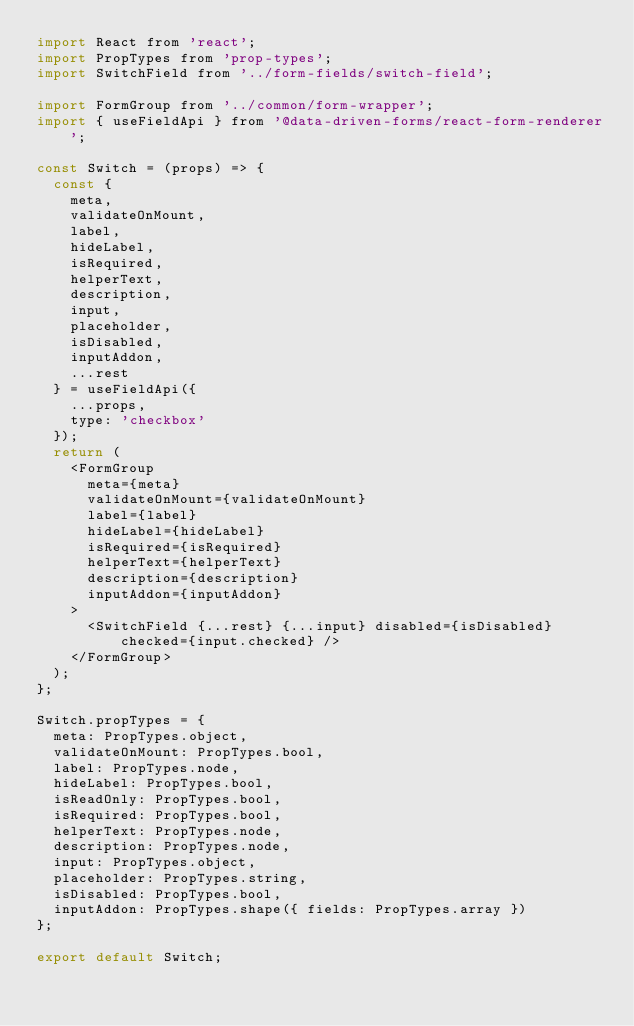Convert code to text. <code><loc_0><loc_0><loc_500><loc_500><_JavaScript_>import React from 'react';
import PropTypes from 'prop-types';
import SwitchField from '../form-fields/switch-field';

import FormGroup from '../common/form-wrapper';
import { useFieldApi } from '@data-driven-forms/react-form-renderer';

const Switch = (props) => {
  const {
    meta,
    validateOnMount,
    label,
    hideLabel,
    isRequired,
    helperText,
    description,
    input,
    placeholder,
    isDisabled,
    inputAddon,
    ...rest
  } = useFieldApi({
    ...props,
    type: 'checkbox'
  });
  return (
    <FormGroup
      meta={meta}
      validateOnMount={validateOnMount}
      label={label}
      hideLabel={hideLabel}
      isRequired={isRequired}
      helperText={helperText}
      description={description}
      inputAddon={inputAddon}
    >
      <SwitchField {...rest} {...input} disabled={isDisabled} checked={input.checked} />
    </FormGroup>
  );
};

Switch.propTypes = {
  meta: PropTypes.object,
  validateOnMount: PropTypes.bool,
  label: PropTypes.node,
  hideLabel: PropTypes.bool,
  isReadOnly: PropTypes.bool,
  isRequired: PropTypes.bool,
  helperText: PropTypes.node,
  description: PropTypes.node,
  input: PropTypes.object,
  placeholder: PropTypes.string,
  isDisabled: PropTypes.bool,
  inputAddon: PropTypes.shape({ fields: PropTypes.array })
};

export default Switch;
</code> 